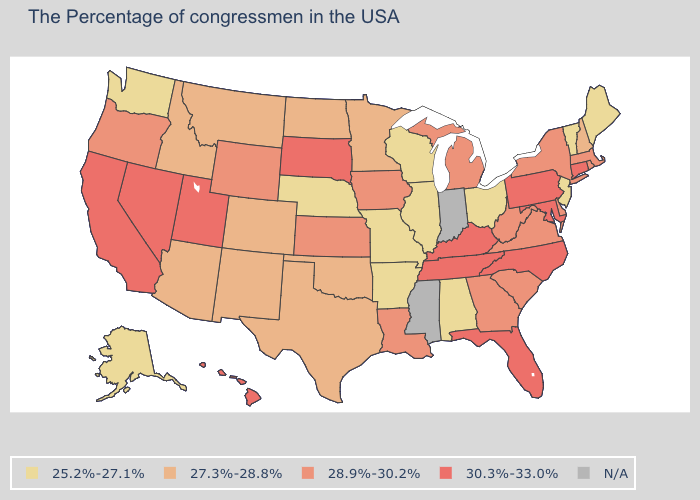What is the lowest value in the South?
Be succinct. 25.2%-27.1%. Which states have the lowest value in the USA?
Write a very short answer. Maine, Vermont, New Jersey, Ohio, Alabama, Wisconsin, Illinois, Missouri, Arkansas, Nebraska, Washington, Alaska. Which states have the highest value in the USA?
Answer briefly. Connecticut, Maryland, Pennsylvania, North Carolina, Florida, Kentucky, Tennessee, South Dakota, Utah, Nevada, California, Hawaii. Which states have the lowest value in the MidWest?
Write a very short answer. Ohio, Wisconsin, Illinois, Missouri, Nebraska. Is the legend a continuous bar?
Write a very short answer. No. What is the highest value in the MidWest ?
Answer briefly. 30.3%-33.0%. What is the value of Florida?
Be succinct. 30.3%-33.0%. Name the states that have a value in the range 27.3%-28.8%?
Concise answer only. New Hampshire, Minnesota, Oklahoma, Texas, North Dakota, Colorado, New Mexico, Montana, Arizona, Idaho. How many symbols are there in the legend?
Write a very short answer. 5. Which states have the highest value in the USA?
Answer briefly. Connecticut, Maryland, Pennsylvania, North Carolina, Florida, Kentucky, Tennessee, South Dakota, Utah, Nevada, California, Hawaii. Name the states that have a value in the range N/A?
Be succinct. Indiana, Mississippi. Name the states that have a value in the range 27.3%-28.8%?
Be succinct. New Hampshire, Minnesota, Oklahoma, Texas, North Dakota, Colorado, New Mexico, Montana, Arizona, Idaho. What is the value of Wisconsin?
Give a very brief answer. 25.2%-27.1%. Does Alabama have the lowest value in the USA?
Write a very short answer. Yes. 